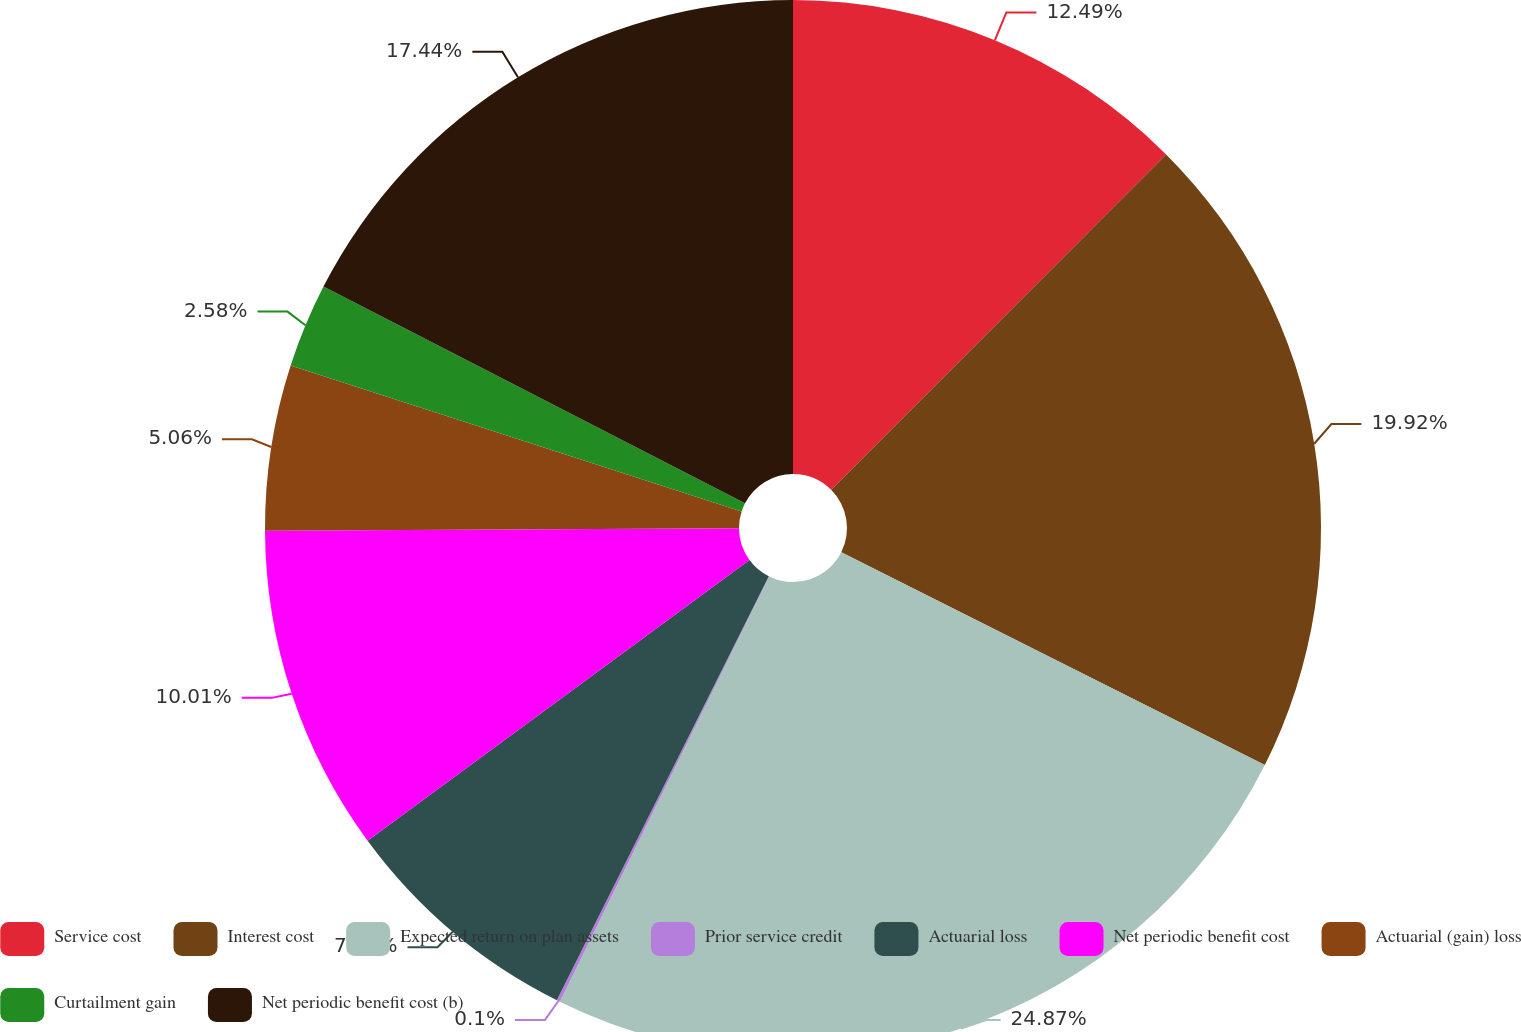Convert chart. <chart><loc_0><loc_0><loc_500><loc_500><pie_chart><fcel>Service cost<fcel>Interest cost<fcel>Expected return on plan assets<fcel>Prior service credit<fcel>Actuarial loss<fcel>Net periodic benefit cost<fcel>Actuarial (gain) loss<fcel>Curtailment gain<fcel>Net periodic benefit cost (b)<nl><fcel>12.49%<fcel>19.92%<fcel>24.87%<fcel>0.1%<fcel>7.53%<fcel>10.01%<fcel>5.06%<fcel>2.58%<fcel>17.44%<nl></chart> 